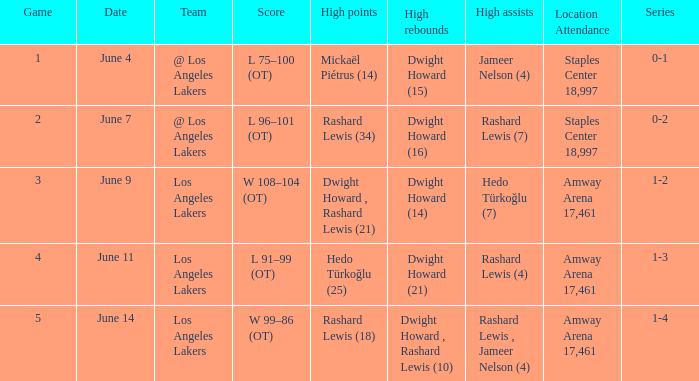What is the definition of high assists, when high rebounds is "dwight howard, rashard lewis (10)"? Rashard Lewis , Jameer Nelson (4). 